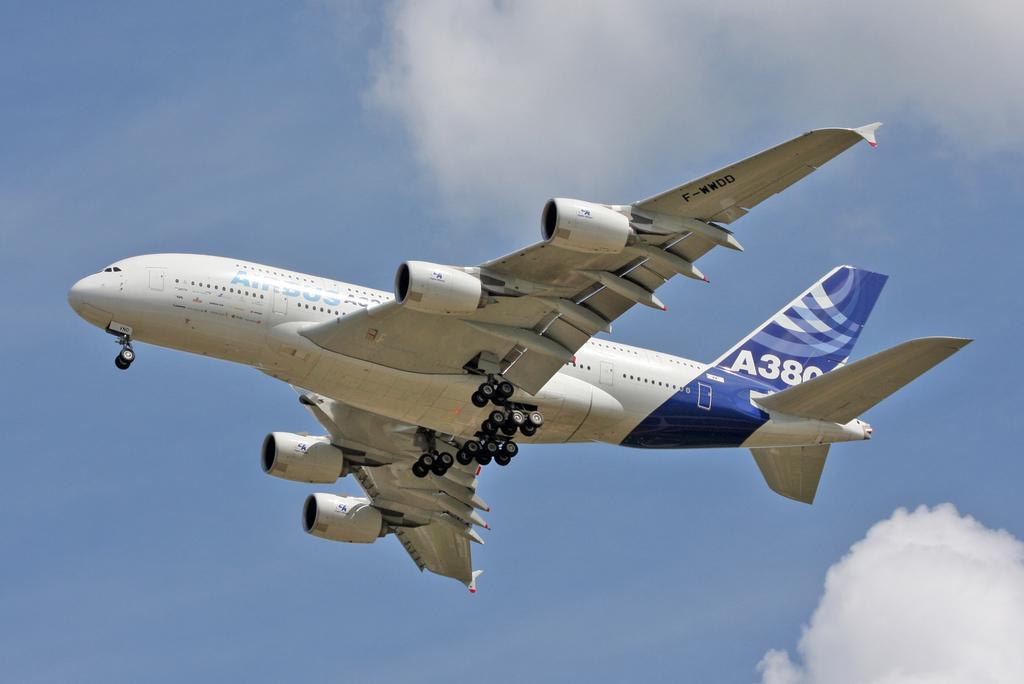<image>
Present a compact description of the photo's key features. An airplane is flying in the air with an A on the tail followed by a number. 